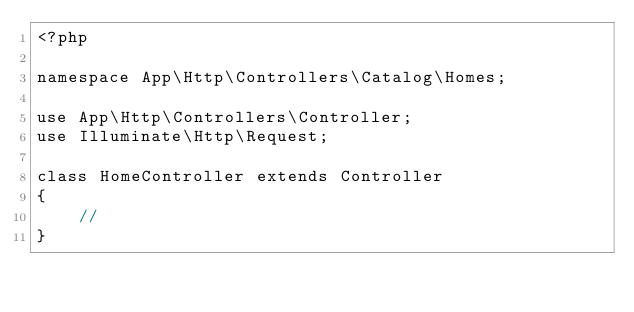Convert code to text. <code><loc_0><loc_0><loc_500><loc_500><_PHP_><?php

namespace App\Http\Controllers\Catalog\Homes;

use App\Http\Controllers\Controller;
use Illuminate\Http\Request;

class HomeController extends Controller
{
    //
}
</code> 